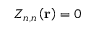<formula> <loc_0><loc_0><loc_500><loc_500>Z _ { n , n } \left ( r \right ) = 0</formula> 